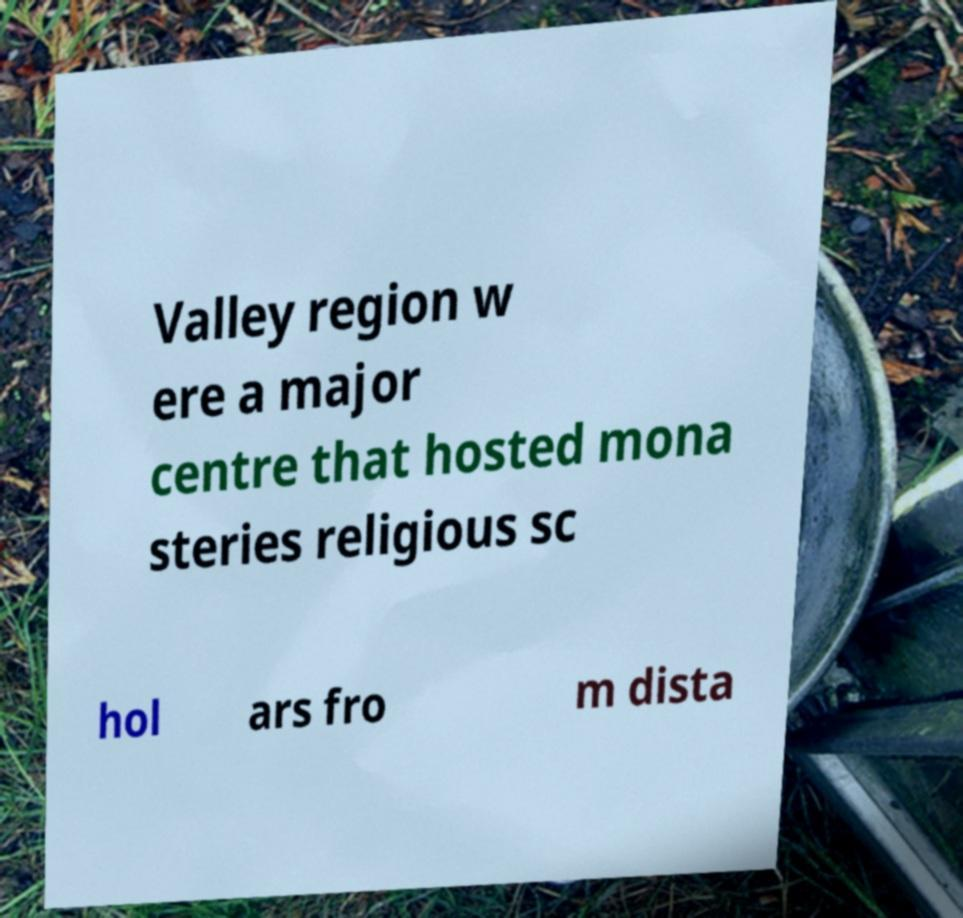There's text embedded in this image that I need extracted. Can you transcribe it verbatim? Valley region w ere a major centre that hosted mona steries religious sc hol ars fro m dista 